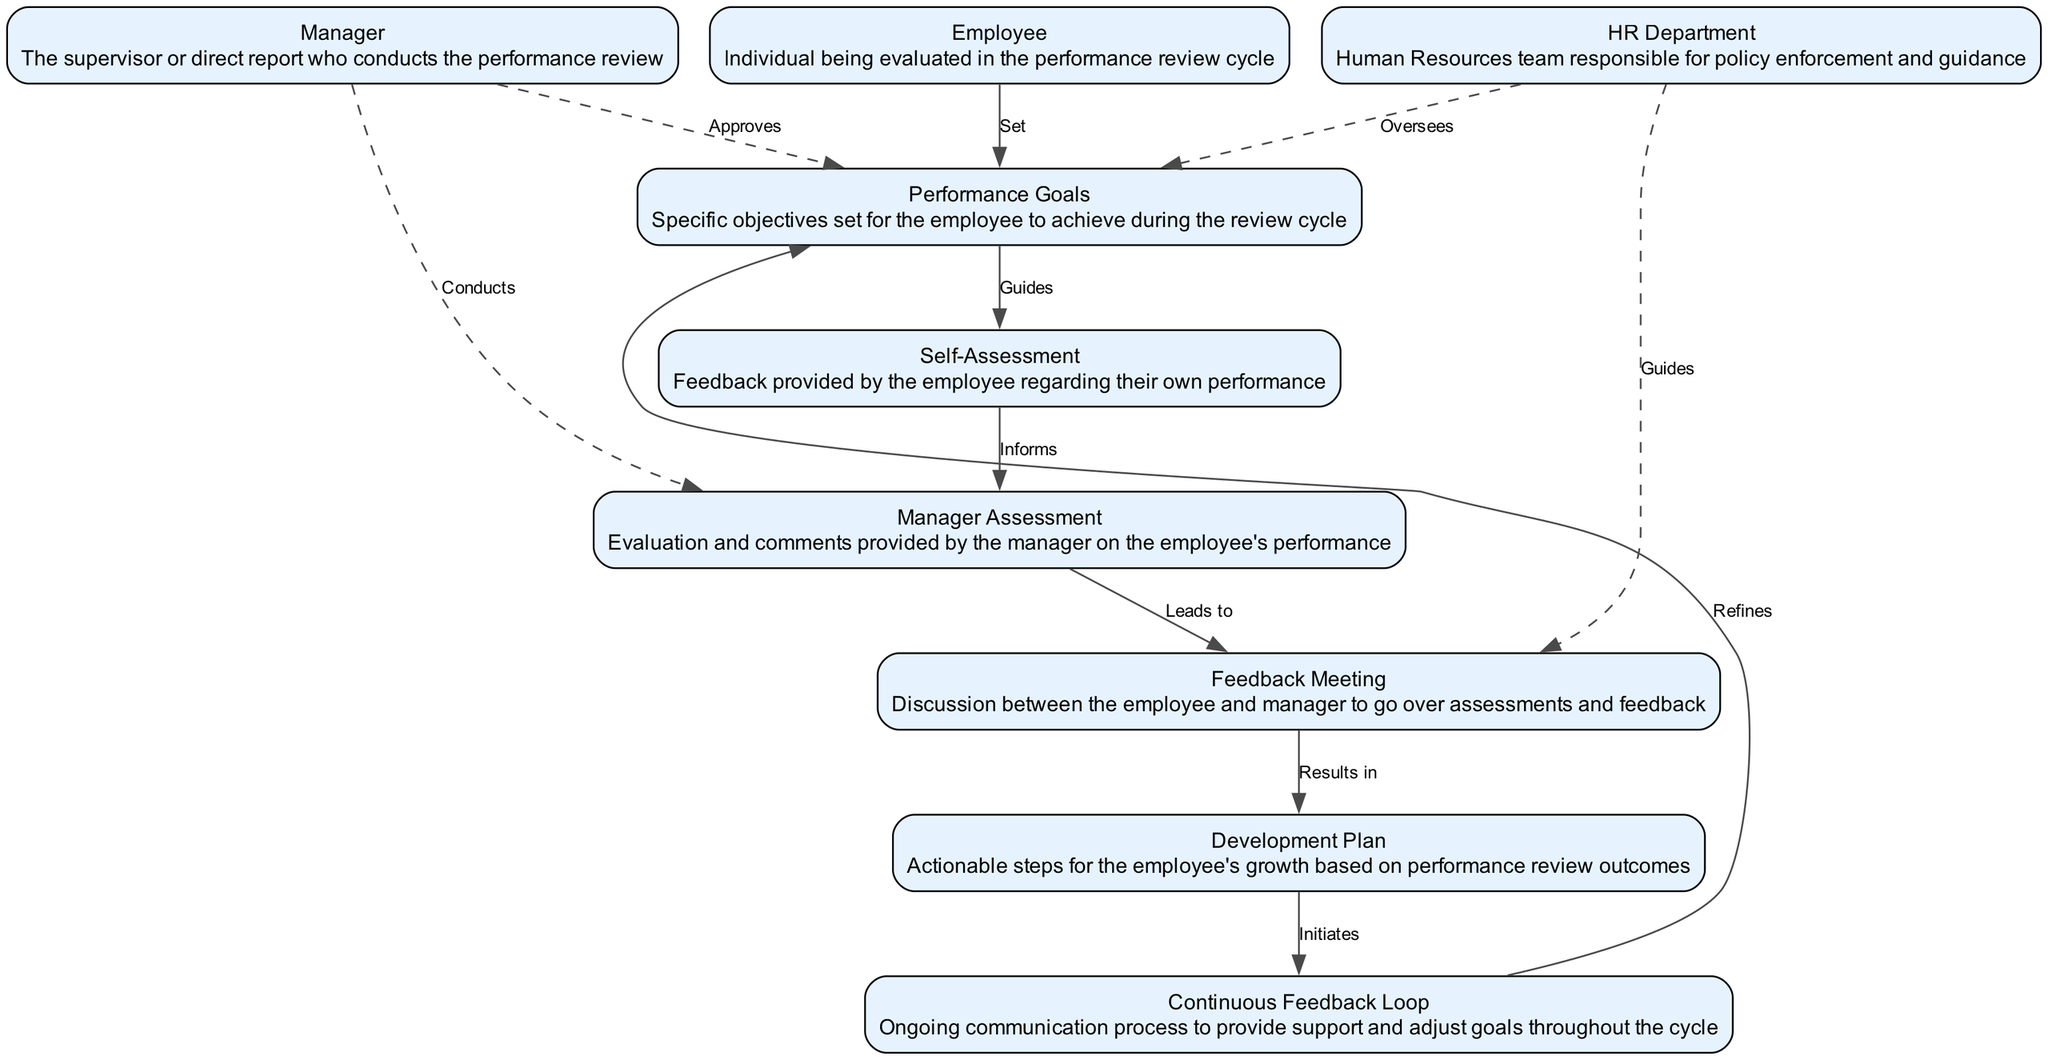What is the first action in the performance review cycle? The first action in the cycle is the 'Set' action from the 'Employee' node to the 'Performance Goals' node, indicating that the employee sets performance goals.
Answer: Set How many main elements are there in the diagram? By counting the nodes presented in the diagram, we see there are nine main elements, which are the different participants and components of the performance review cycle.
Answer: Nine What does the 'Manager' do regarding the 'Performance Goals'? The 'Manager' approves the performance goals as indicated by the dashed line connecting these two nodes labeled 'Approves'.
Answer: Approves Which node is the final outcome of the feedback meeting? The 'Development Plan' node is the final outcome, as it follows the 'Feedback Meeting' node with the action 'Results in'.
Answer: Development Plan What action initiates the 'Continuous Feedback Loop'? The 'Development Plan' node initiates the 'Continuous Feedback Loop' as indicated by the 'Initiates' label on the edge connecting these two nodes.
Answer: Initiates What type of feedback is primarily provided by the 'Self-Assessment'? The 'Self-Assessment' provides feedback that 'Informs' the 'Manager Assessment', indicating that it is the employee's perspective on their own performance.
Answer: Informs How does the HR Department engage in the review cycle? The HR Department oversees the performance goals and guides the feedback meeting, as shown by the dashed lines connecting it to these nodes.
Answer: Oversees and Guides Which relationship shows the iterative nature of the performance review cycle? The relationship labeled 'Refines' shows the iterative nature, connecting the 'Continuous Feedback Loop' back to 'Performance Goals', indicating ongoing adjustments.
Answer: Refines What role does the 'Feedback Meeting' play after assessments? The 'Feedback Meeting' serves as a discussion point leading to the 'Development Plan', indicated by the action 'Results in' which follows it.
Answer: Results in 